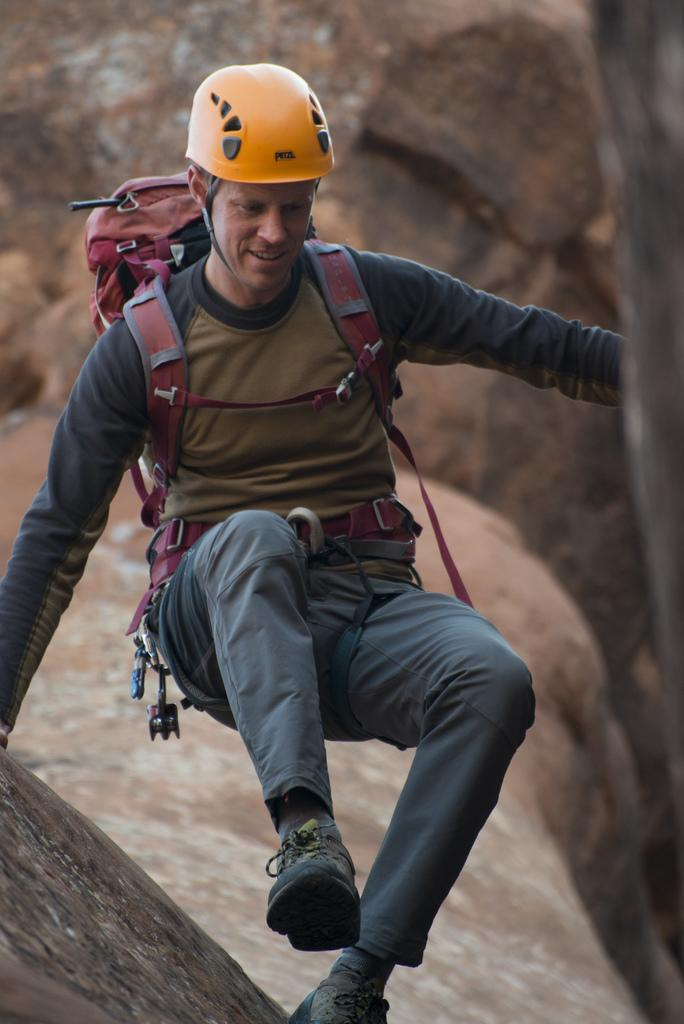Who is present in the image? There is a man in the image. What is the man wearing on his head? The man is wearing a helmet. What type of clothing is the man wearing on his upper body? The man is wearing a t-shirt. What type of clothing is the man wearing on his lower body? The man is wearing jeans. What type of footwear is the man wearing? The man is wearing shoes. What is the man carrying in the image? The man is carrying a bag. What is the man standing near in the image? The man is standing near stones. How many chairs are visible in the image? There are no chairs visible in the image. What type of plant is growing near the stones? There is no plant visible near the stones in the image. 